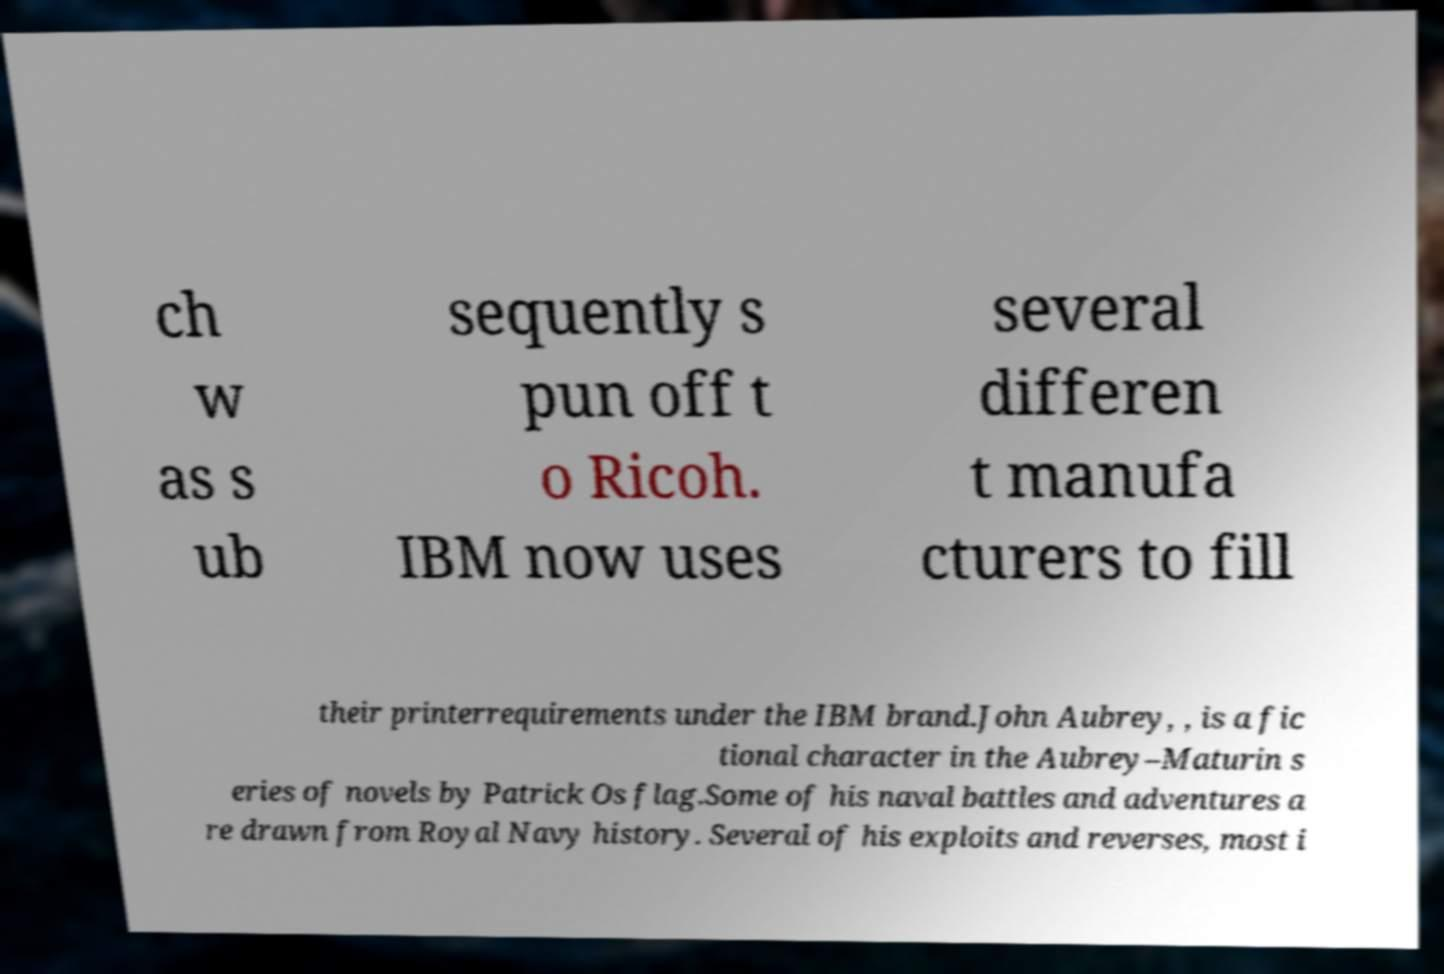Can you accurately transcribe the text from the provided image for me? ch w as s ub sequently s pun off t o Ricoh. IBM now uses several differen t manufa cturers to fill their printerrequirements under the IBM brand.John Aubrey, , is a fic tional character in the Aubrey–Maturin s eries of novels by Patrick Os flag.Some of his naval battles and adventures a re drawn from Royal Navy history. Several of his exploits and reverses, most i 